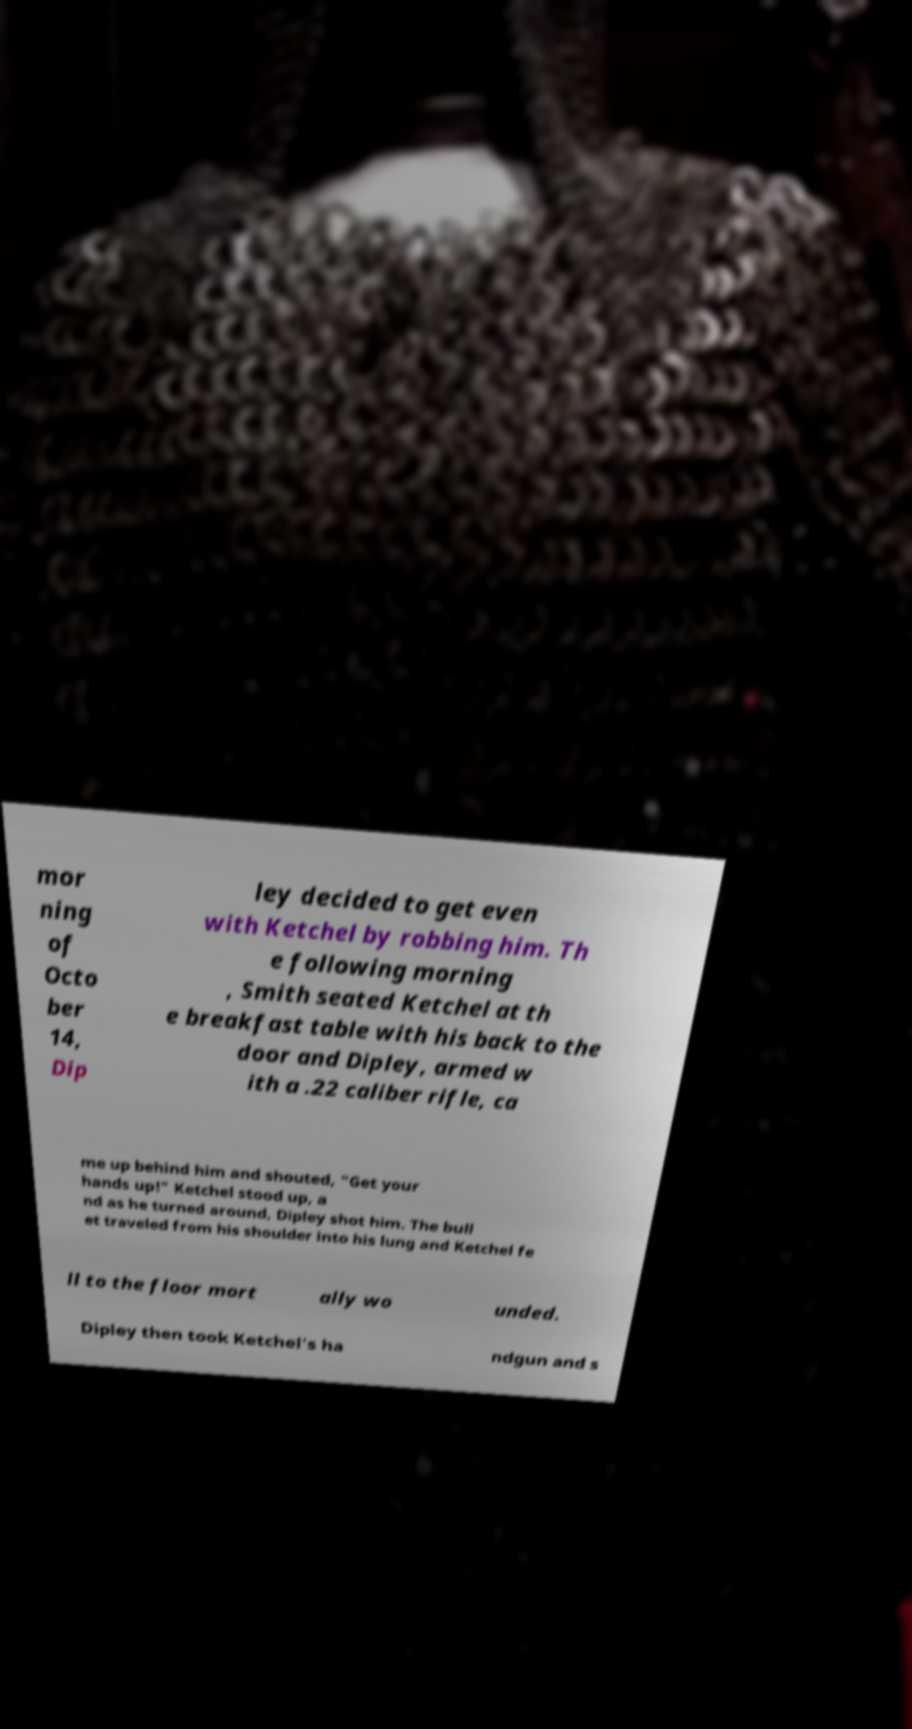There's text embedded in this image that I need extracted. Can you transcribe it verbatim? mor ning of Octo ber 14, Dip ley decided to get even with Ketchel by robbing him. Th e following morning , Smith seated Ketchel at th e breakfast table with his back to the door and Dipley, armed w ith a .22 caliber rifle, ca me up behind him and shouted, "Get your hands up!" Ketchel stood up, a nd as he turned around, Dipley shot him. The bull et traveled from his shoulder into his lung and Ketchel fe ll to the floor mort ally wo unded. Dipley then took Ketchel's ha ndgun and s 